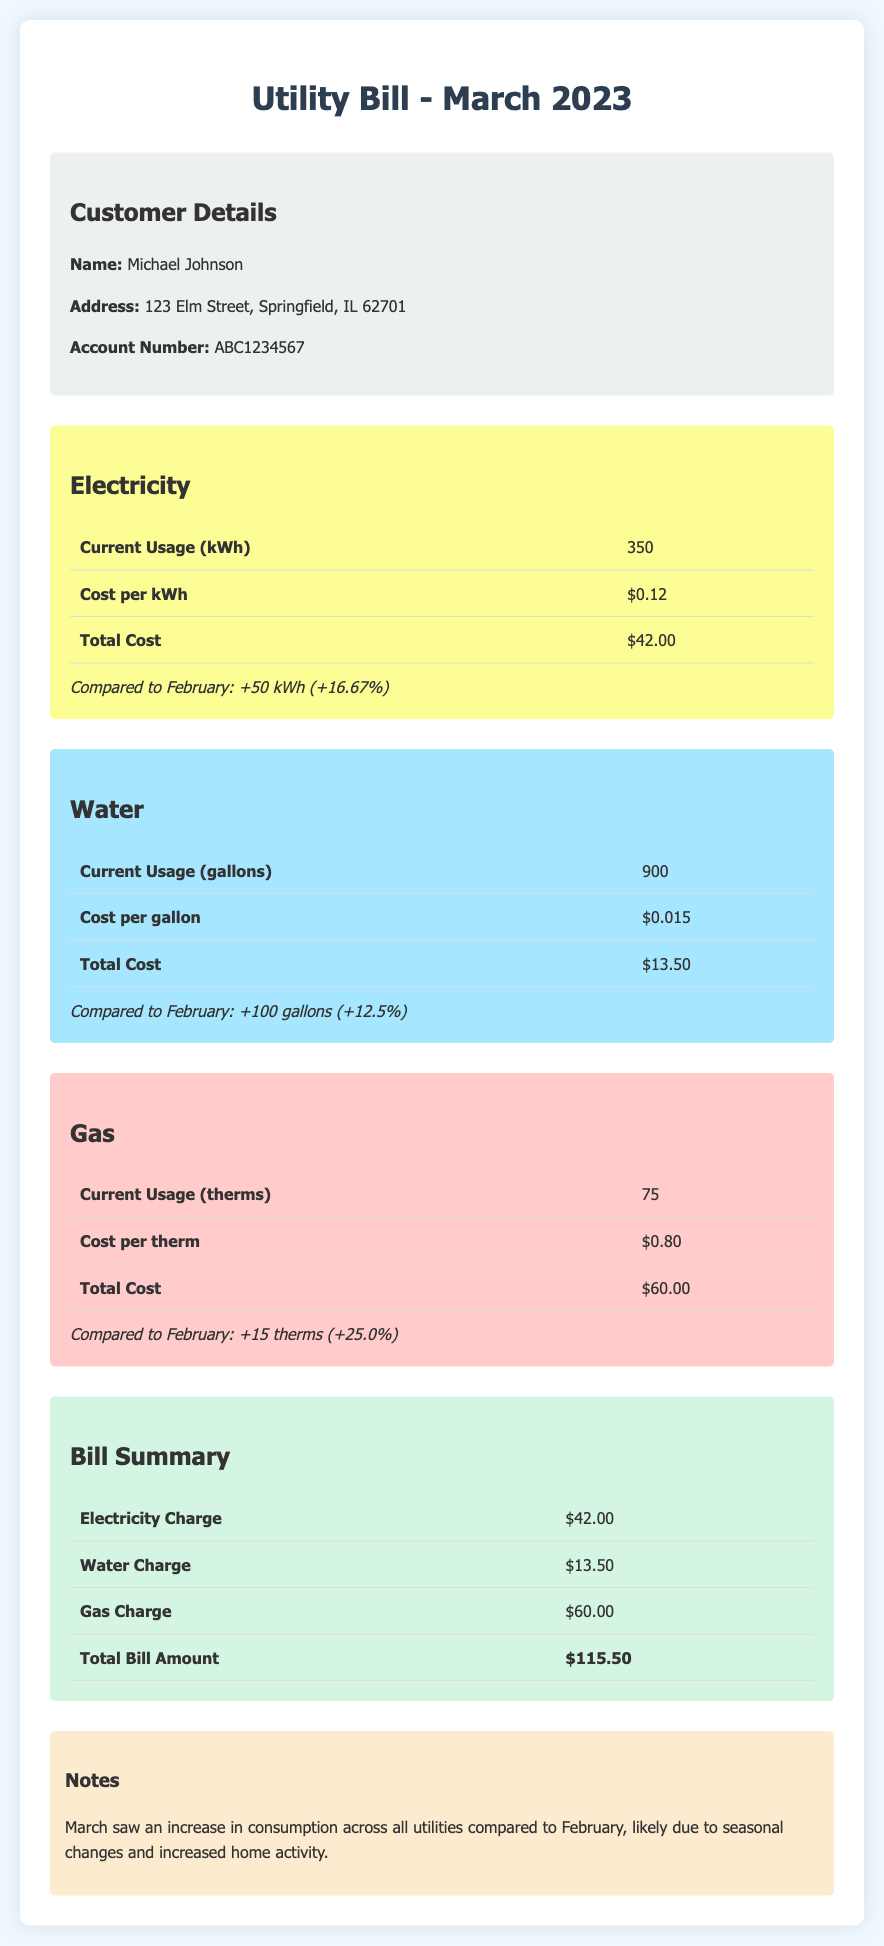What is the total bill amount? The total bill amount is found in the summary section, which includes all utility charges.
Answer: $115.50 What is the current electricity usage? The current electricity usage is specified in the electricity section.
Answer: 350 kWh How much did the gas cost per therm? The cost per therm is stated in the gas section of the bill.
Answer: $0.80 What was the increase in water usage compared to February? The increase in water usage is detailed in the water section with a percentage.
Answer: +100 gallons (+12.5%) What is the customer's name? The customer's name is provided in the customer information section of the document.
Answer: Michael Johnson How much was the electricity charge? The electricity charge can be found in the summary table.
Answer: $42.00 What was the total increase in gas usage compared to February? The total increase in gas usage is specified in the gas section of the bill.
Answer: +15 therms (+25.0%) What type of document is this? The document is clearly indicated at the top as a utility bill for a specific month.
Answer: Utility Bill What consumption type shows the highest percentage increase? By comparing the increases provided for each utility, we find the one with the largest percentage increase.
Answer: Gas 